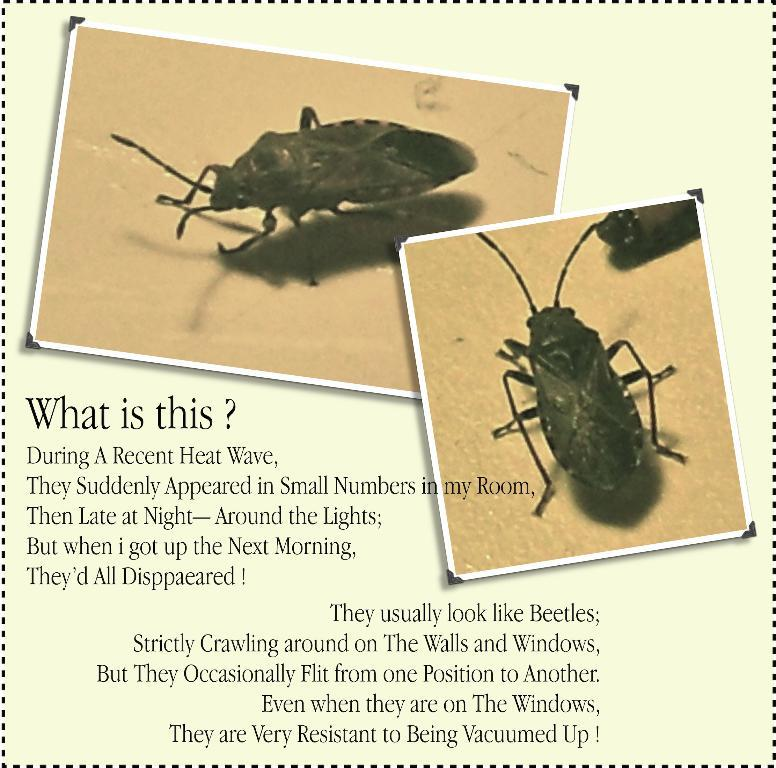What is present on the poster in the image? The poster contains text and pictures of insects. Can you describe the content of the poster? The poster has text and pictures of insects. What type of pen is being used to draw on the canvas in the image? There is no canvas or pen present in the image; it only features a poster with text and pictures of insects. 